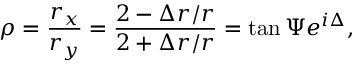<formula> <loc_0><loc_0><loc_500><loc_500>\rho = \frac { r _ { x } } { r _ { y } } = \frac { 2 - \Delta r / r } { 2 + \Delta r / r } = \tan \Psi e ^ { i \Delta } ,</formula> 